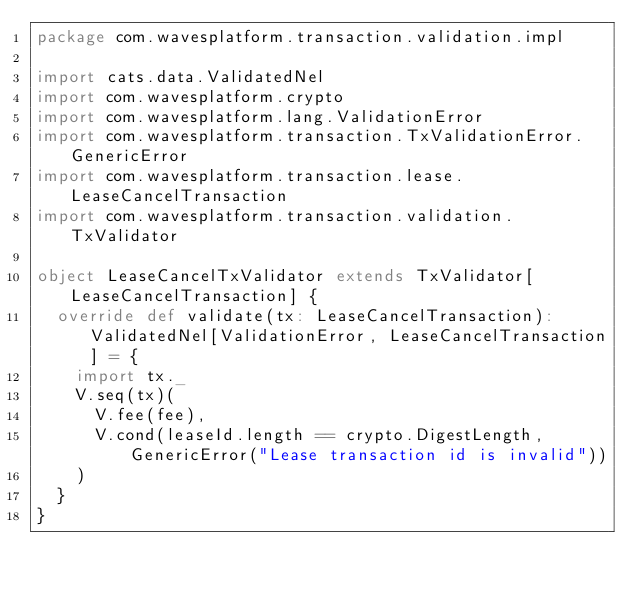<code> <loc_0><loc_0><loc_500><loc_500><_Scala_>package com.wavesplatform.transaction.validation.impl

import cats.data.ValidatedNel
import com.wavesplatform.crypto
import com.wavesplatform.lang.ValidationError
import com.wavesplatform.transaction.TxValidationError.GenericError
import com.wavesplatform.transaction.lease.LeaseCancelTransaction
import com.wavesplatform.transaction.validation.TxValidator

object LeaseCancelTxValidator extends TxValidator[LeaseCancelTransaction] {
  override def validate(tx: LeaseCancelTransaction): ValidatedNel[ValidationError, LeaseCancelTransaction] = {
    import tx._
    V.seq(tx)(
      V.fee(fee),
      V.cond(leaseId.length == crypto.DigestLength, GenericError("Lease transaction id is invalid"))
    )
  }
}
</code> 